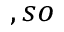<formula> <loc_0><loc_0><loc_500><loc_500>, s o</formula> 